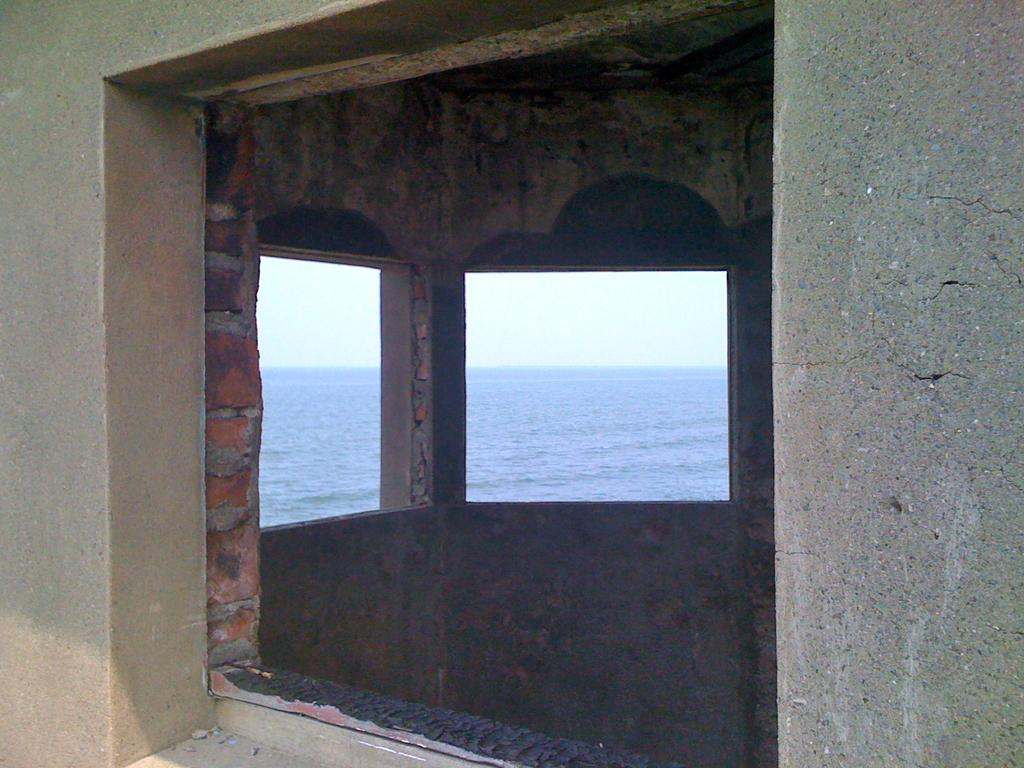What type of structure is present in the image? There is a building in the image. What natural element can be seen alongside the building? There is water visible in the image. What is visible above the building and water? The sky is visible in the image. What type of jewel is embedded in the building's facade in the image? There is no jewel present in the image; the building and its features are not described in detail. 